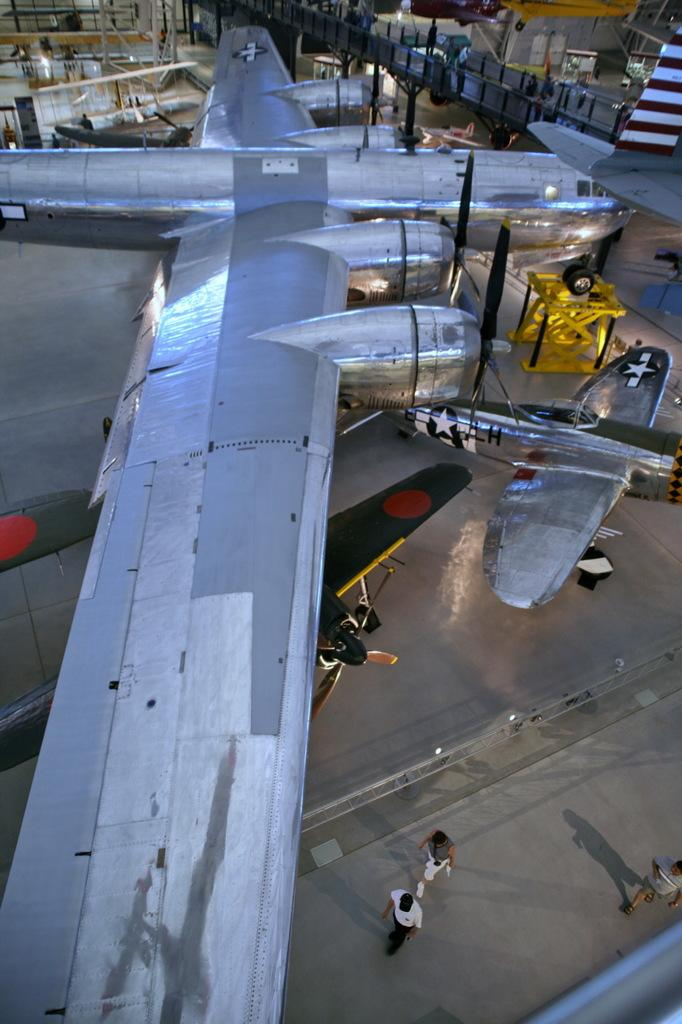What is the main subject of the picture? The main subject of the picture is an airplane. Are there any other types of aircraft in the picture? Yes, there are small planes in the picture. What are the people in the picture doing? The people in the picture are walking. What kind of equipment is present in the picture? There is a lifting crane in the picture. What type of location does the image appear to depict? The image appears to depict an airplane manufacturing unit. What type of plough is being used to cultivate the field in the image? There is no field or plough present in the image; it depicts an airplane manufacturing unit. What kind of hall is visible in the background of the image? There is no hall visible in the image; it depicts an airplane manufacturing unit with an airplane, small planes, people walking, a lifting crane, and a possible manufacturing setting. 